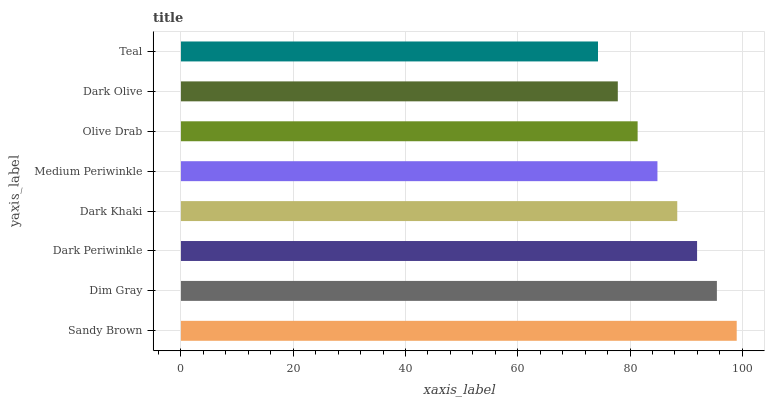Is Teal the minimum?
Answer yes or no. Yes. Is Sandy Brown the maximum?
Answer yes or no. Yes. Is Dim Gray the minimum?
Answer yes or no. No. Is Dim Gray the maximum?
Answer yes or no. No. Is Sandy Brown greater than Dim Gray?
Answer yes or no. Yes. Is Dim Gray less than Sandy Brown?
Answer yes or no. Yes. Is Dim Gray greater than Sandy Brown?
Answer yes or no. No. Is Sandy Brown less than Dim Gray?
Answer yes or no. No. Is Dark Khaki the high median?
Answer yes or no. Yes. Is Medium Periwinkle the low median?
Answer yes or no. Yes. Is Olive Drab the high median?
Answer yes or no. No. Is Dark Olive the low median?
Answer yes or no. No. 